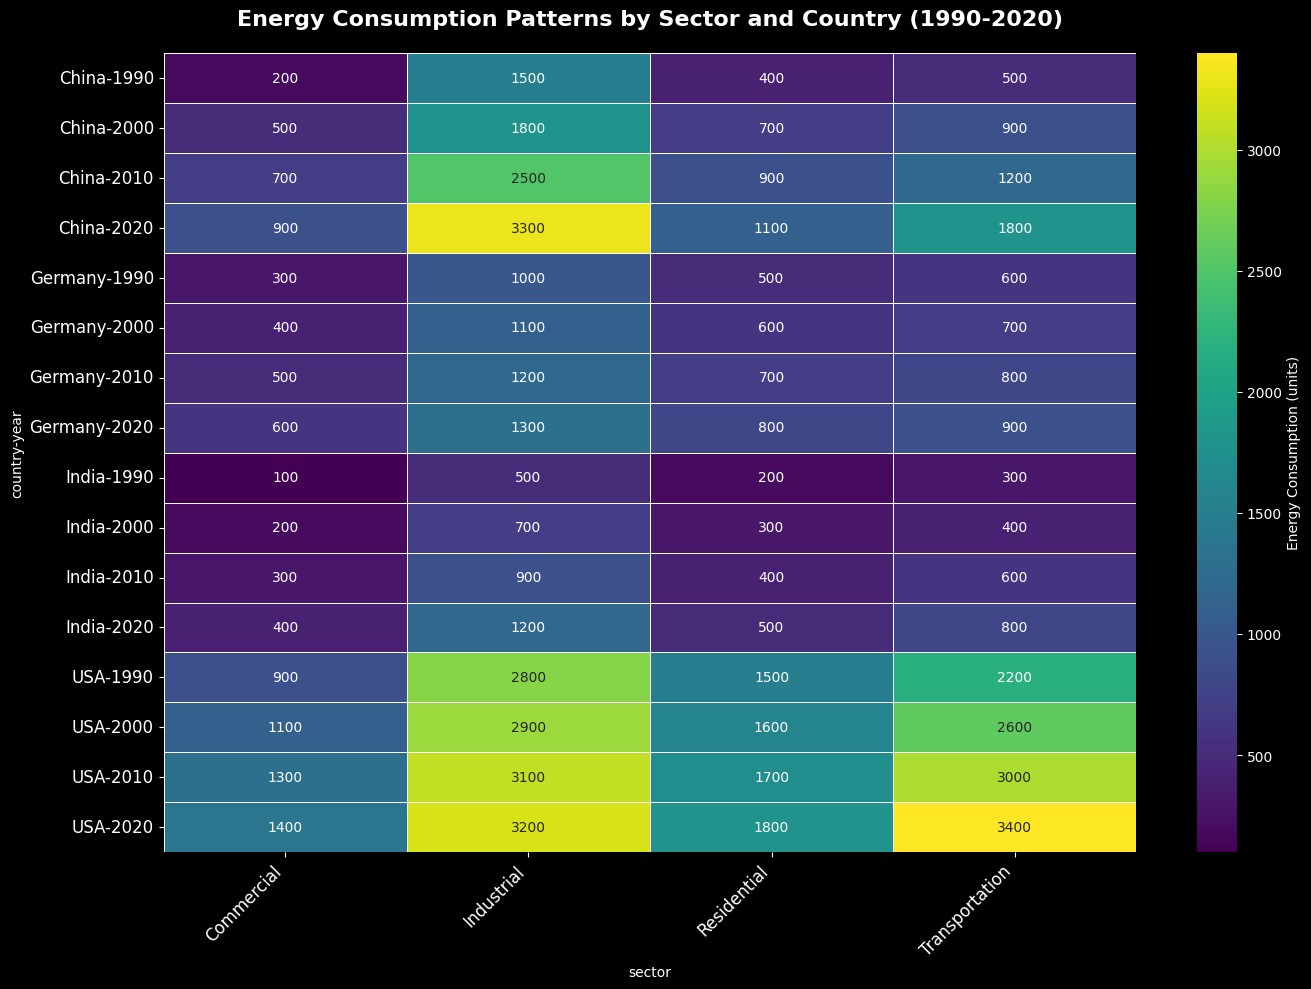What's the highest energy consumption for the USA in the transportation sector? Locate the USA row, then look for the highest value in the Transportation column; it's 3400 in 2020.
Answer: 3400 Which country had the lowest industrial energy consumption in 1990? Go to the 1990 row, then find the smallest value in the Industrial column; it's India with 500 units.
Answer: India How did Germany's residential energy consumption change from 1990 to 2020? Find Germany's residential consumption for 1990 and 2020 (500 and 800, respectively). Calculate the difference: 800 - 500 = 300.
Answer: Increased by 300 What is the total energy consumption for residential sectors in China across all years? Add up the residential values for China: 400 (1990) + 700 (2000) + 900 (2010) + 1100 (2020) = 3100.
Answer: 3100 Which year saw the highest combined industrial energy consumption for all countries? For each year, sum the values in the Industrial column: 1990 (5800), 2000 (6500), 2010 (7700), 2020 (9000). The highest is in 2020 with 9000 units.
Answer: 2020 How does India's transportation energy consumption in 2020 compare to its transportation energy consumption in 2000? Find India's Transportation values for 2020 and 2000 (800 and 400). Compare them: 800 is double 400.
Answer: Doubled Which sector has the most consistent energy consumption pattern across all countries over time? Observe each sector column; the Commercial sector's values seem less variable compared to others.
Answer: Commercial Between USA, China, Germany, and India, which country's industrial energy consumption increased the most from 1990 to 2020? Calculate the increase for each country: USA (3200-2800=400), China (3300-1500=1800), Germany (1300-1000=300), India (1200-500=700). China shows the highest increase (1800).
Answer: China How does the energy consumption distribution in 2020 compare visually across sectors for all countries? Observe the 2020 row; Industrial and Transportation have darker shades indicating higher values, while Commercial is lighter.
Answer: Industrial and Transportation are higher compared to Commercial and Residential 